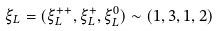Convert formula to latex. <formula><loc_0><loc_0><loc_500><loc_500>\xi _ { L } = ( \xi _ { L } ^ { + + } , \xi _ { L } ^ { + } , \xi _ { L } ^ { 0 } ) \sim ( 1 , 3 , 1 , 2 )</formula> 